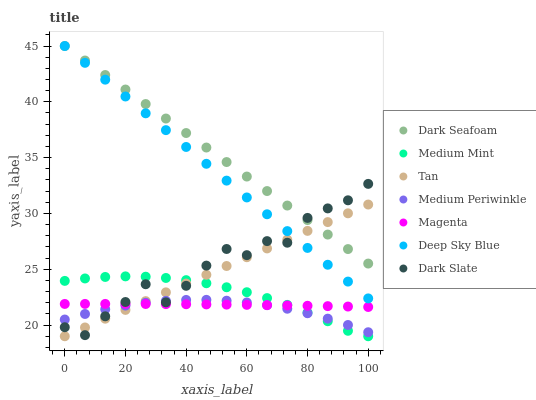Does Medium Periwinkle have the minimum area under the curve?
Answer yes or no. Yes. Does Dark Seafoam have the maximum area under the curve?
Answer yes or no. Yes. Does Dark Slate have the minimum area under the curve?
Answer yes or no. No. Does Dark Slate have the maximum area under the curve?
Answer yes or no. No. Is Deep Sky Blue the smoothest?
Answer yes or no. Yes. Is Dark Slate the roughest?
Answer yes or no. Yes. Is Medium Periwinkle the smoothest?
Answer yes or no. No. Is Medium Periwinkle the roughest?
Answer yes or no. No. Does Medium Mint have the lowest value?
Answer yes or no. Yes. Does Medium Periwinkle have the lowest value?
Answer yes or no. No. Does Deep Sky Blue have the highest value?
Answer yes or no. Yes. Does Medium Periwinkle have the highest value?
Answer yes or no. No. Is Medium Periwinkle less than Dark Seafoam?
Answer yes or no. Yes. Is Deep Sky Blue greater than Medium Mint?
Answer yes or no. Yes. Does Tan intersect Dark Seafoam?
Answer yes or no. Yes. Is Tan less than Dark Seafoam?
Answer yes or no. No. Is Tan greater than Dark Seafoam?
Answer yes or no. No. Does Medium Periwinkle intersect Dark Seafoam?
Answer yes or no. No. 